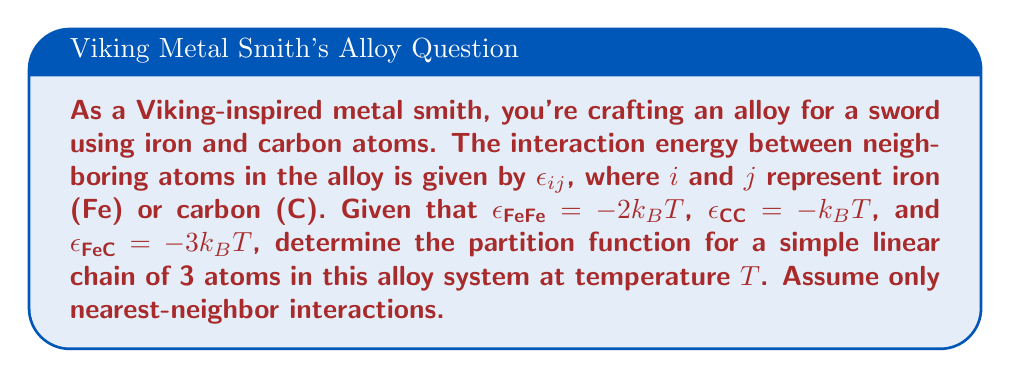Can you solve this math problem? To solve this problem, we'll follow these steps:

1) First, we need to identify all possible configurations of the 3-atom chain. There are 8 possible configurations:
   Fe-Fe-Fe, Fe-Fe-C, Fe-C-Fe, C-Fe-Fe, Fe-C-C, C-Fe-C, C-C-Fe, C-C-C

2) For each configuration, we calculate the total energy:
   
   Fe-Fe-Fe: $E = 2\epsilon_{FeFe} = -4k_BT$
   Fe-Fe-C: $E = \epsilon_{FeFe} + \epsilon_{FeC} = -5k_BT$
   Fe-C-Fe: $E = 2\epsilon_{FeC} = -6k_BT$
   C-Fe-Fe: $E = \epsilon_{FeFe} + \epsilon_{FeC} = -5k_BT$
   Fe-C-C: $E = \epsilon_{FeC} + \epsilon_{CC} = -4k_BT$
   C-Fe-C: $E = 2\epsilon_{FeC} = -6k_BT$
   C-C-Fe: $E = \epsilon_{FeC} + \epsilon_{CC} = -4k_BT$
   C-C-C: $E = 2\epsilon_{CC} = -2k_BT$

3) The partition function is the sum of Boltzmann factors for all possible configurations:

   $$Z = \sum_i e^{-E_i/k_BT}$$

4) Substituting the energies:

   $$Z = e^{4} + 2e^{5} + 2e^{6} + 2e^{4} + e^{2}$$

5) Simplifying:

   $$Z = e^{2} + 3e^{4} + 2e^{5} + 2e^{6}$$

This is the partition function for the 3-atom chain in the alloy system.
Answer: $$Z = e^{2} + 3e^{4} + 2e^{5} + 2e^{6}$$ 